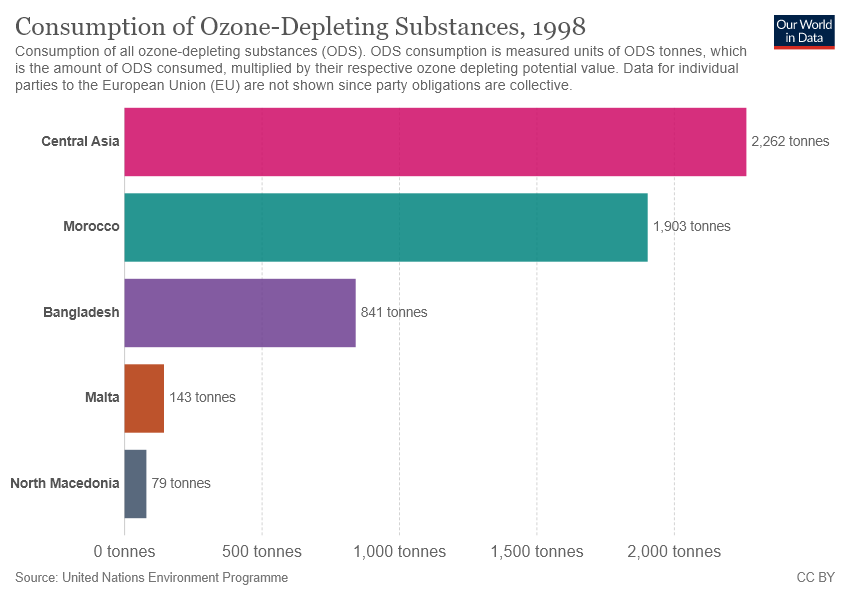Draw attention to some important aspects in this diagram. The value of Malta is 143. The difference between Central Asia and Morocco is greater than the value of Malta. 